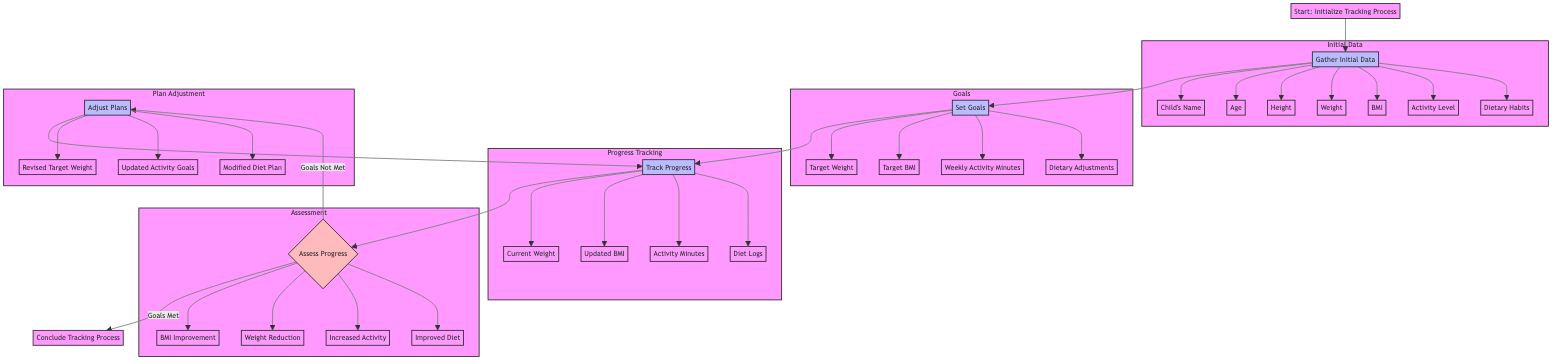What is the first step in the tracking process? The first step, as indicated by the Start node, is "Initialize Tracking Process." This node is the entry point of the diagram.
Answer: Initialize Tracking Process How many fields are included in the initial data collection? By examining the Gather Initial Data node, we see it consists of seven data fields related to the child's health and lifestyle.
Answer: 7 What is the frequency of progress tracking? Within the Track Progress node, it states that the monitoring frequency is "Weekly." This clearly outlines how often progress should be updated.
Answer: Weekly What happens if the goals are not met? According to the Assess Progress node, if the goals are not met, the diagram flows to Adjust Plans, suggesting that adjustments need to be made to the original goals and strategies.
Answer: Adjust Plans Which criteria are used to assess progress? The Assess Progress node outlines four specific criteria used for evaluation: BMI Improvement, Weight Reduction, Increased Physical Activity, and Improved Dietary Habits.
Answer: BMI Improvement, Weight Reduction, Increased Physical Activity, Improved Dietary Habits Where does the process go after assessing progress if goals are met? From the Assess Progress node, if the goals are met, the flowchart points directly to the End node, indicating the conclusion of the tracking process.
Answer: Conclude Tracking Process What are the revised fields included in the adjustment plans? The Adjust Plans node outlines three fields that will be revised if necessary: Revised Target Weight, Updated Activity Goals, and Modified Diet Plan.
Answer: Revised Target Weight, Updated Activity Goals, Modified Diet Plan How many goals are defined in the Set Goals node? The Set Goals node contains four specific goals related to the child's health, as stated in the corresponding section of the diagram.
Answer: 4 